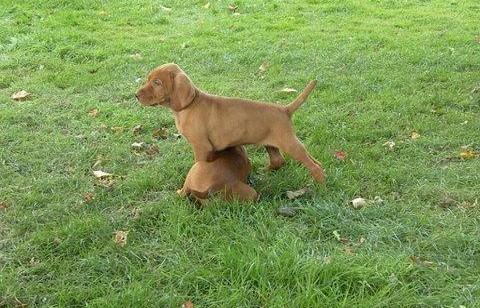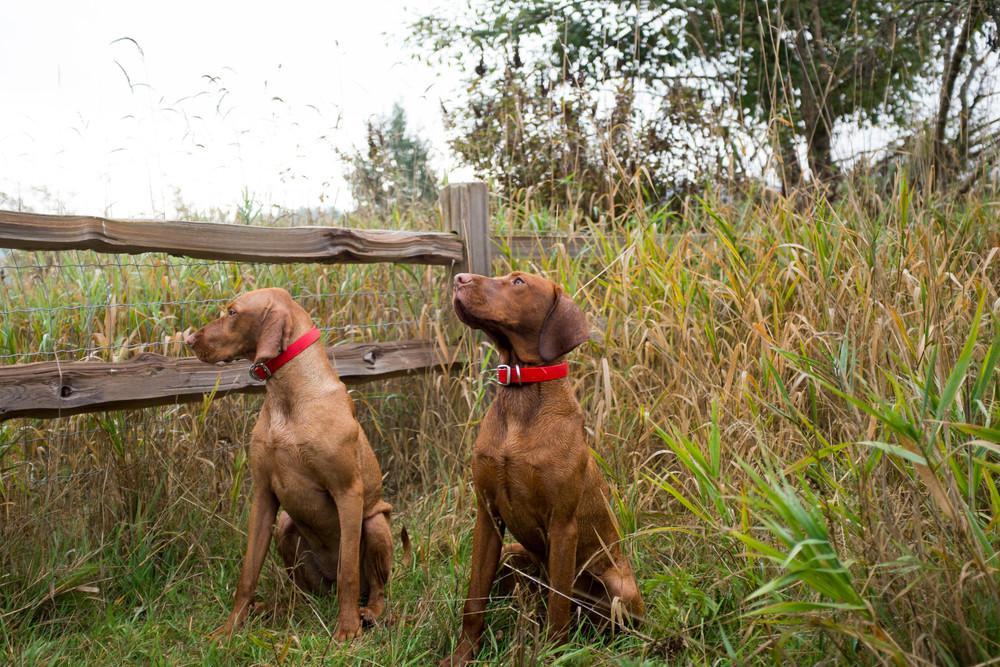The first image is the image on the left, the second image is the image on the right. Examine the images to the left and right. Is the description "One dog's teeth are visible." accurate? Answer yes or no. No. The first image is the image on the left, the second image is the image on the right. Evaluate the accuracy of this statement regarding the images: "A total of three red-orange dogs, all wearing collars, are shown - and the right image contains two side-by-side dogs gazing in the same direction.". Is it true? Answer yes or no. No. 